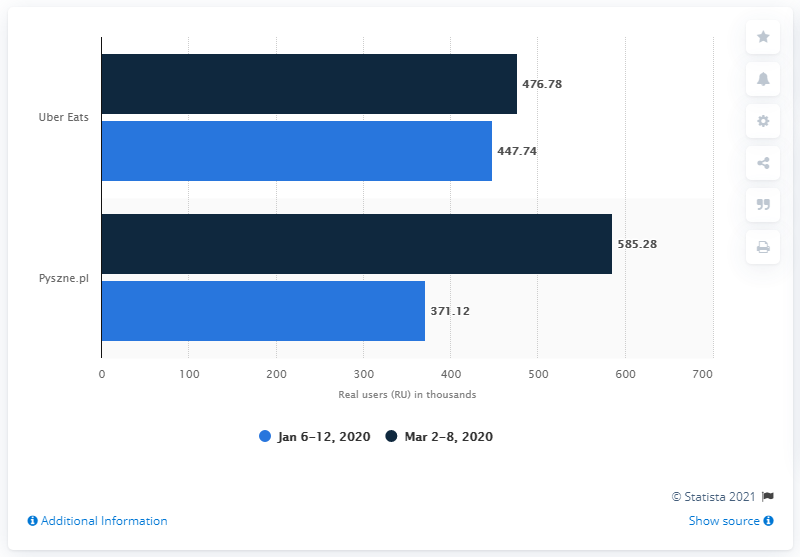Highlight a few significant elements in this photo. The value of a light blue bar is 818.86 and.. The period from March 2nd to March 8th, 2020 had the highest growth in the number of users. 